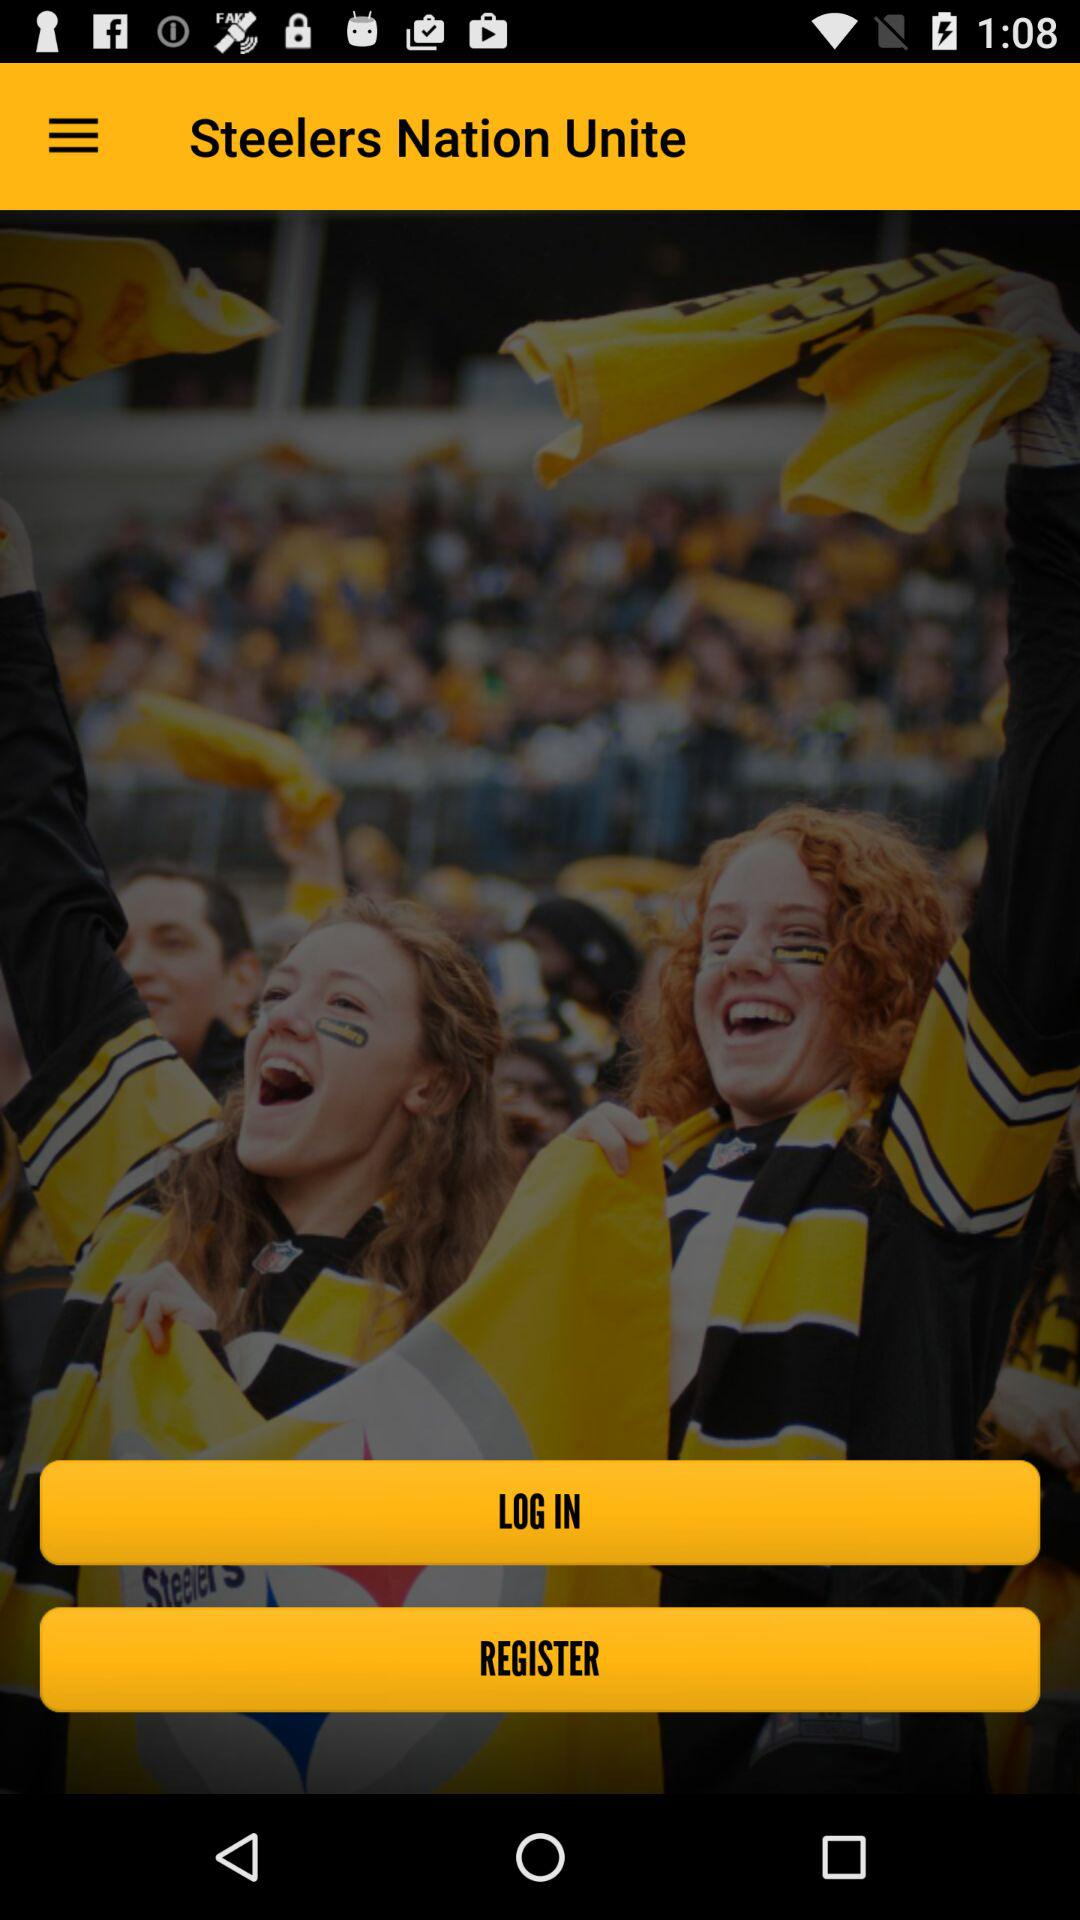What is the app name?
When the provided information is insufficient, respond with <no answer>. <no answer> 